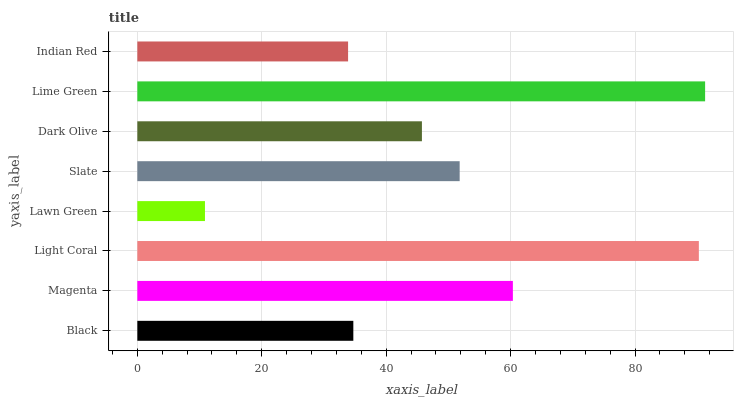Is Lawn Green the minimum?
Answer yes or no. Yes. Is Lime Green the maximum?
Answer yes or no. Yes. Is Magenta the minimum?
Answer yes or no. No. Is Magenta the maximum?
Answer yes or no. No. Is Magenta greater than Black?
Answer yes or no. Yes. Is Black less than Magenta?
Answer yes or no. Yes. Is Black greater than Magenta?
Answer yes or no. No. Is Magenta less than Black?
Answer yes or no. No. Is Slate the high median?
Answer yes or no. Yes. Is Dark Olive the low median?
Answer yes or no. Yes. Is Dark Olive the high median?
Answer yes or no. No. Is Indian Red the low median?
Answer yes or no. No. 